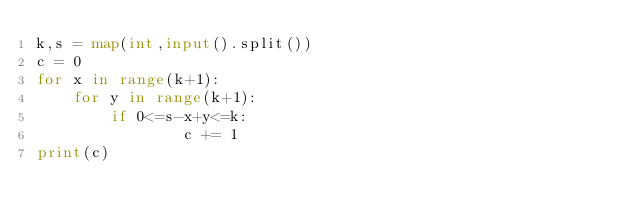<code> <loc_0><loc_0><loc_500><loc_500><_Python_>k,s = map(int,input().split())
c = 0
for x in range(k+1):
    for y in range(k+1):
        if 0<=s-x+y<=k:
                c += 1
print(c)</code> 